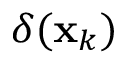Convert formula to latex. <formula><loc_0><loc_0><loc_500><loc_500>\delta ( x _ { k } )</formula> 